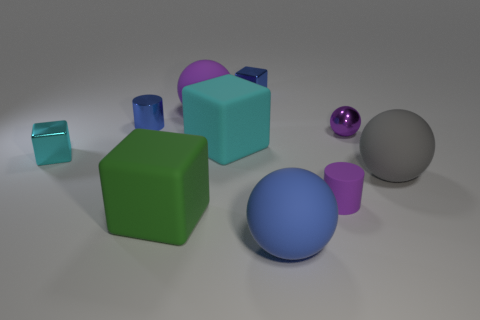Are there any other things that have the same color as the small rubber cylinder?
Your answer should be very brief. Yes. Is there another gray object of the same shape as the gray object?
Offer a terse response. No. What is the shape of the green object that is the same size as the gray matte thing?
Your answer should be very brief. Cube. The tiny cylinder behind the large sphere that is to the right of the purple ball on the right side of the large blue ball is made of what material?
Give a very brief answer. Metal. Is the blue shiny cube the same size as the gray thing?
Provide a short and direct response. No. What material is the big purple ball?
Your answer should be compact. Rubber. There is another ball that is the same color as the shiny ball; what is it made of?
Make the answer very short. Rubber. Does the blue object that is in front of the gray sphere have the same shape as the gray rubber object?
Provide a succinct answer. Yes. How many objects are either small brown metal balls or matte objects?
Keep it short and to the point. 6. Is the material of the blue thing to the left of the blue metal cube the same as the small cyan block?
Give a very brief answer. Yes. 